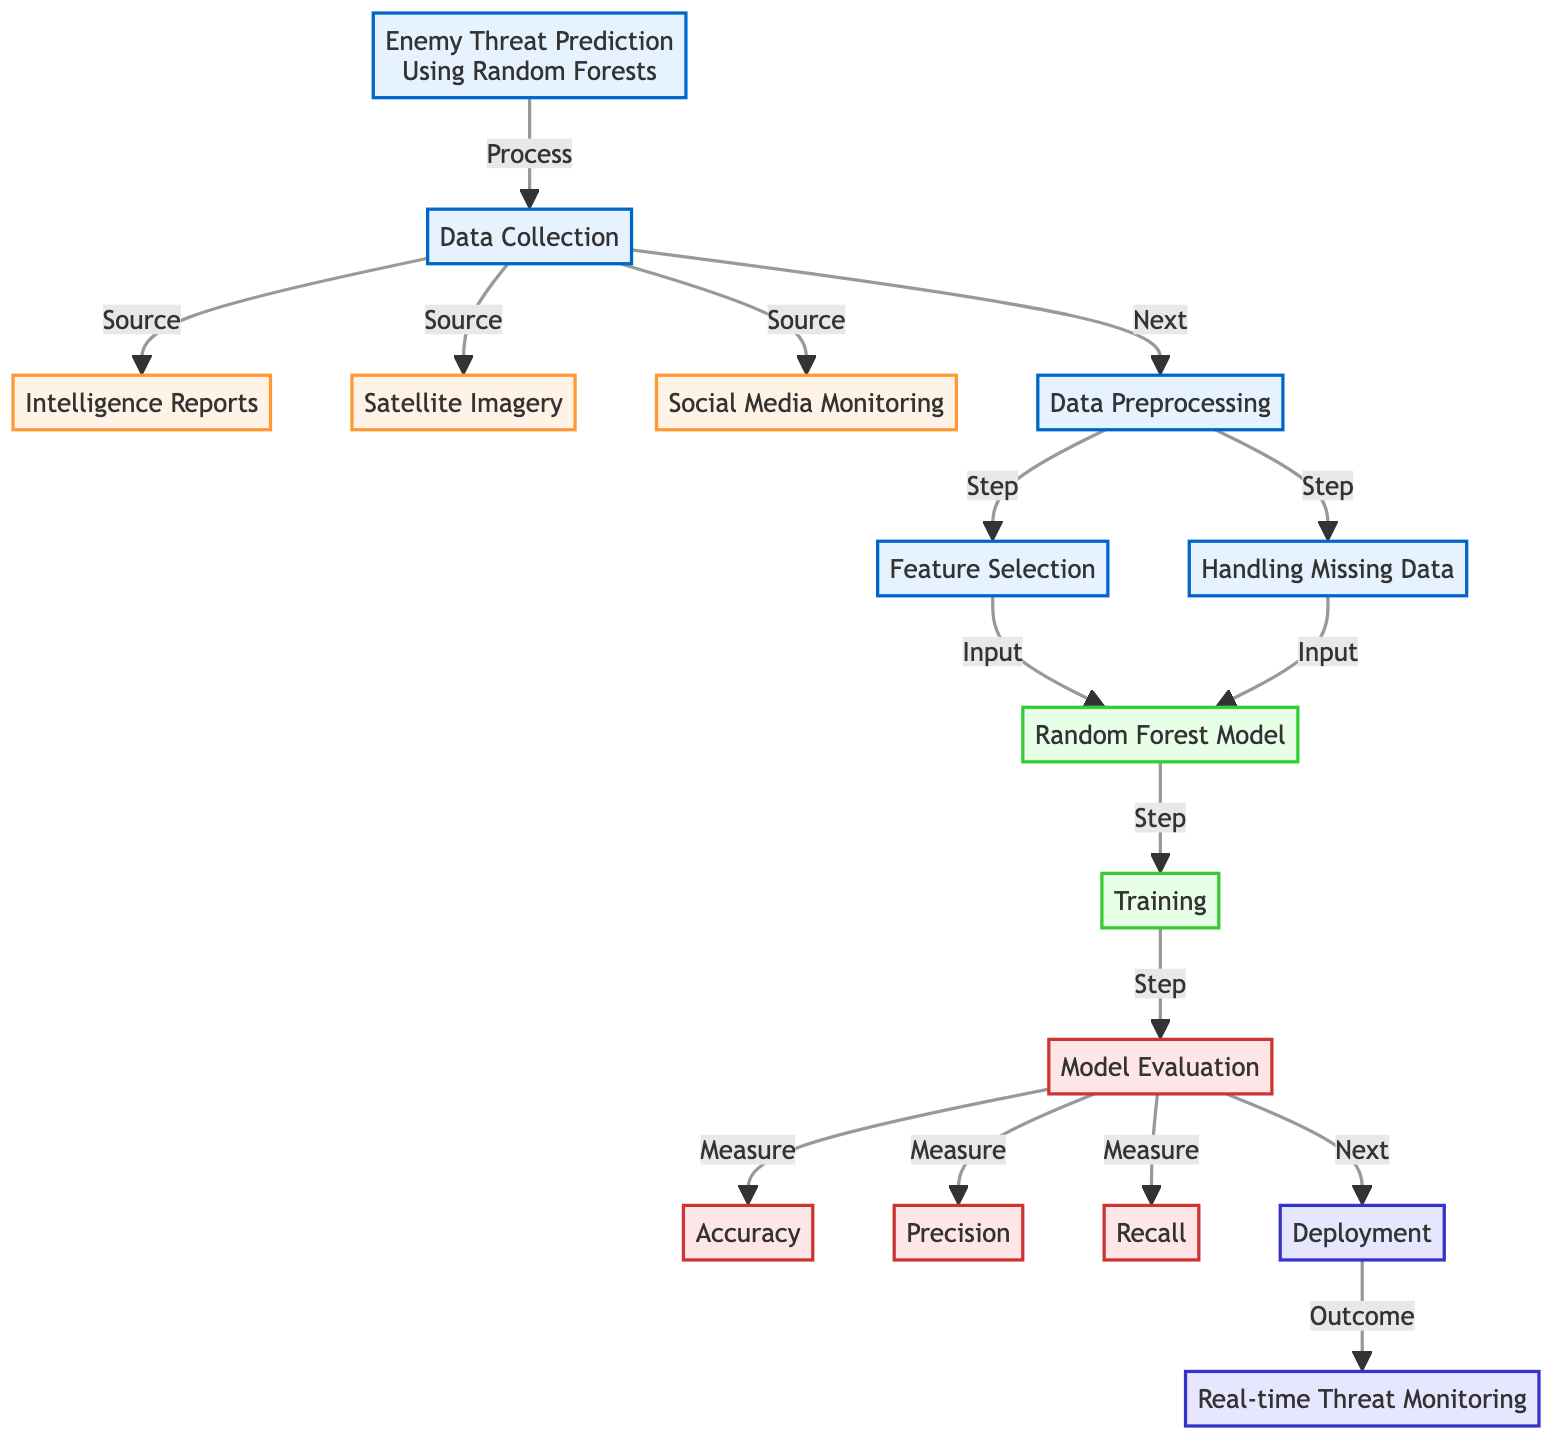What is the first step in the threat prediction process? The diagram indicates that "Data Collection" is the first step in the process of enemy threat prediction. It directly follows from the main title of the diagram, which outlines the overall process.
Answer: Data Collection How many sources contribute to the data collection phase? The diagram lists three distinct sources that contribute to the data collection phase: "Intelligence Reports," "Satellite Imagery," and "Social Media Monitoring." Therefore, the answer is derived directly from counting these sources.
Answer: Three What is the purpose of the data preprocessing step? The data preprocessing step is essential for preparing the collected data for modeling. It involves "Feature Selection" and "Handling Missing Data," both of which are necessary for ensuring the quality and relevance of data before feeding it into the model.
Answer: Prepare data Which model is used for enemy threat prediction? The diagram clearly states that the "Random Forest Model" is utilized for enemy threat prediction, highlighting the specific algorithm employed in this machine learning process.
Answer: Random Forest Model What measures are used for model evaluation? The diagram indicates three specific metrics: "Accuracy," "Precision," and "Recall," which are employed to evaluate the performance of the model after its training phase. The answer is obtained by identifying these evaluation measures listed in the corresponding node.
Answer: Accuracy, Precision, Recall What is the final outcome of the deployment step? The final outcome of the deployment step is "Real-time Threat Monitoring," which follows directly from the model evaluation phase and signifies the operational implementation of the threat prediction model.
Answer: Real-time Threat Monitoring How does the data collection phase transition to preprocessing? The transition from "Data Collection" to "Data Preprocessing" is explicitly marked in the diagram as a "Next" step, indicating a direct flow from collecting data to preparing the data for further processing.
Answer: Next Which step in the diagram directly follows model evaluation? The step that directly follows "Model Evaluation" is "Deployment," which takes the results from the evaluation phase and implements them into operational usage, as shown by the flow in the diagram.
Answer: Deployment What is a key processing task in data preprocessing? A key processing task in the data preprocessing phase includes "Feature Selection," which involves identifying and selecting relevant variables for training the model, as indicated in the diagram.
Answer: Feature Selection 